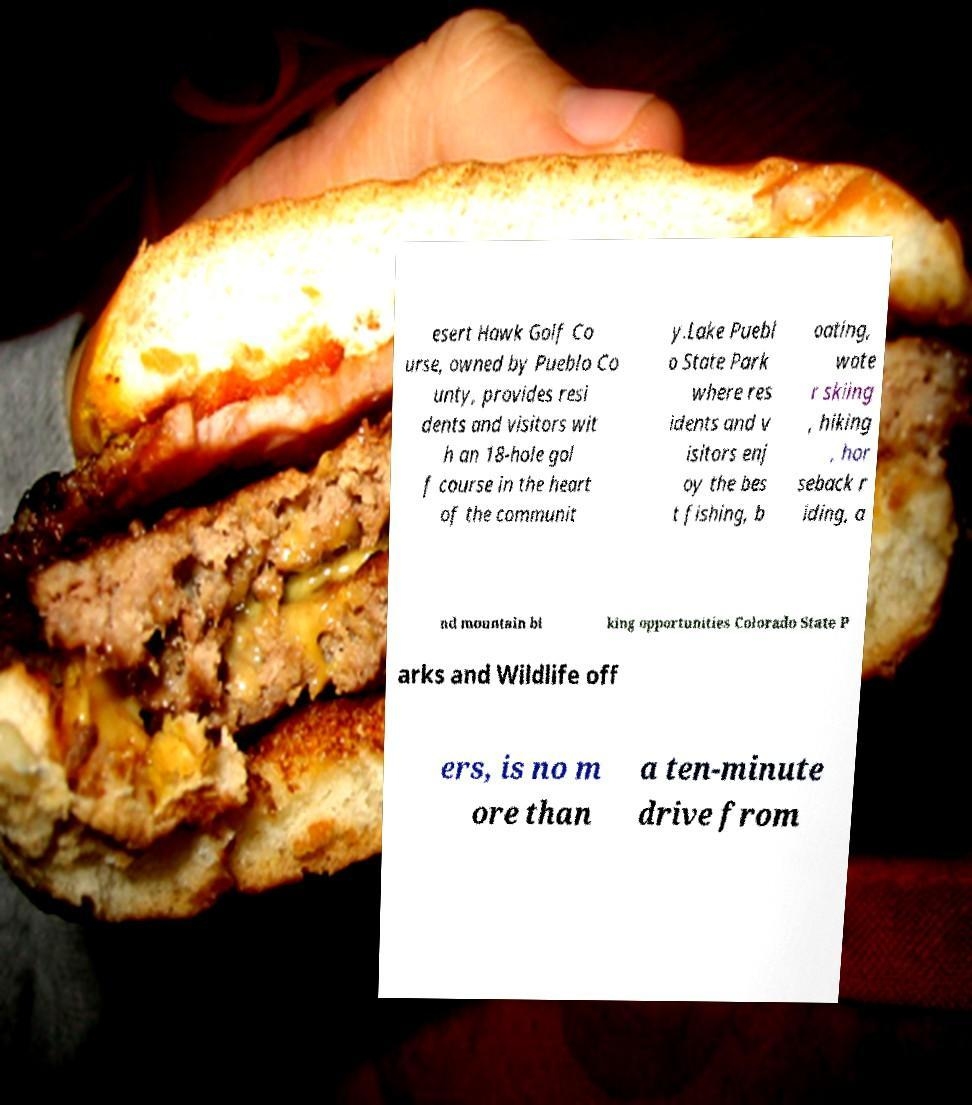Can you accurately transcribe the text from the provided image for me? esert Hawk Golf Co urse, owned by Pueblo Co unty, provides resi dents and visitors wit h an 18-hole gol f course in the heart of the communit y.Lake Puebl o State Park where res idents and v isitors enj oy the bes t fishing, b oating, wate r skiing , hiking , hor seback r iding, a nd mountain bi king opportunities Colorado State P arks and Wildlife off ers, is no m ore than a ten-minute drive from 